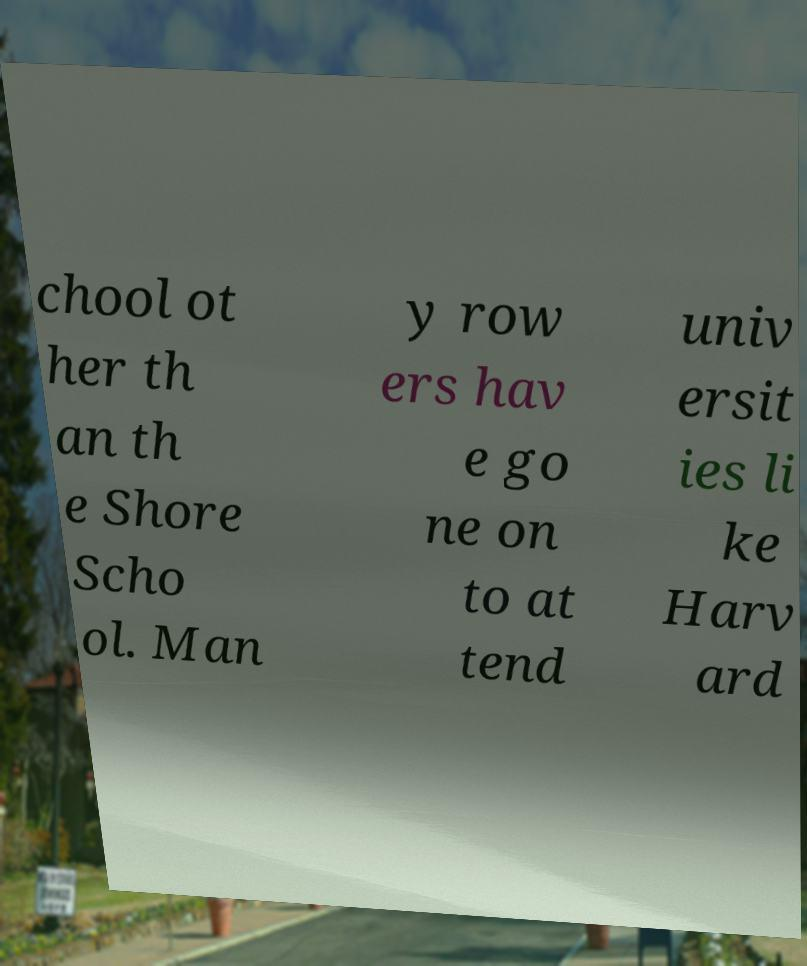What messages or text are displayed in this image? I need them in a readable, typed format. chool ot her th an th e Shore Scho ol. Man y row ers hav e go ne on to at tend univ ersit ies li ke Harv ard 